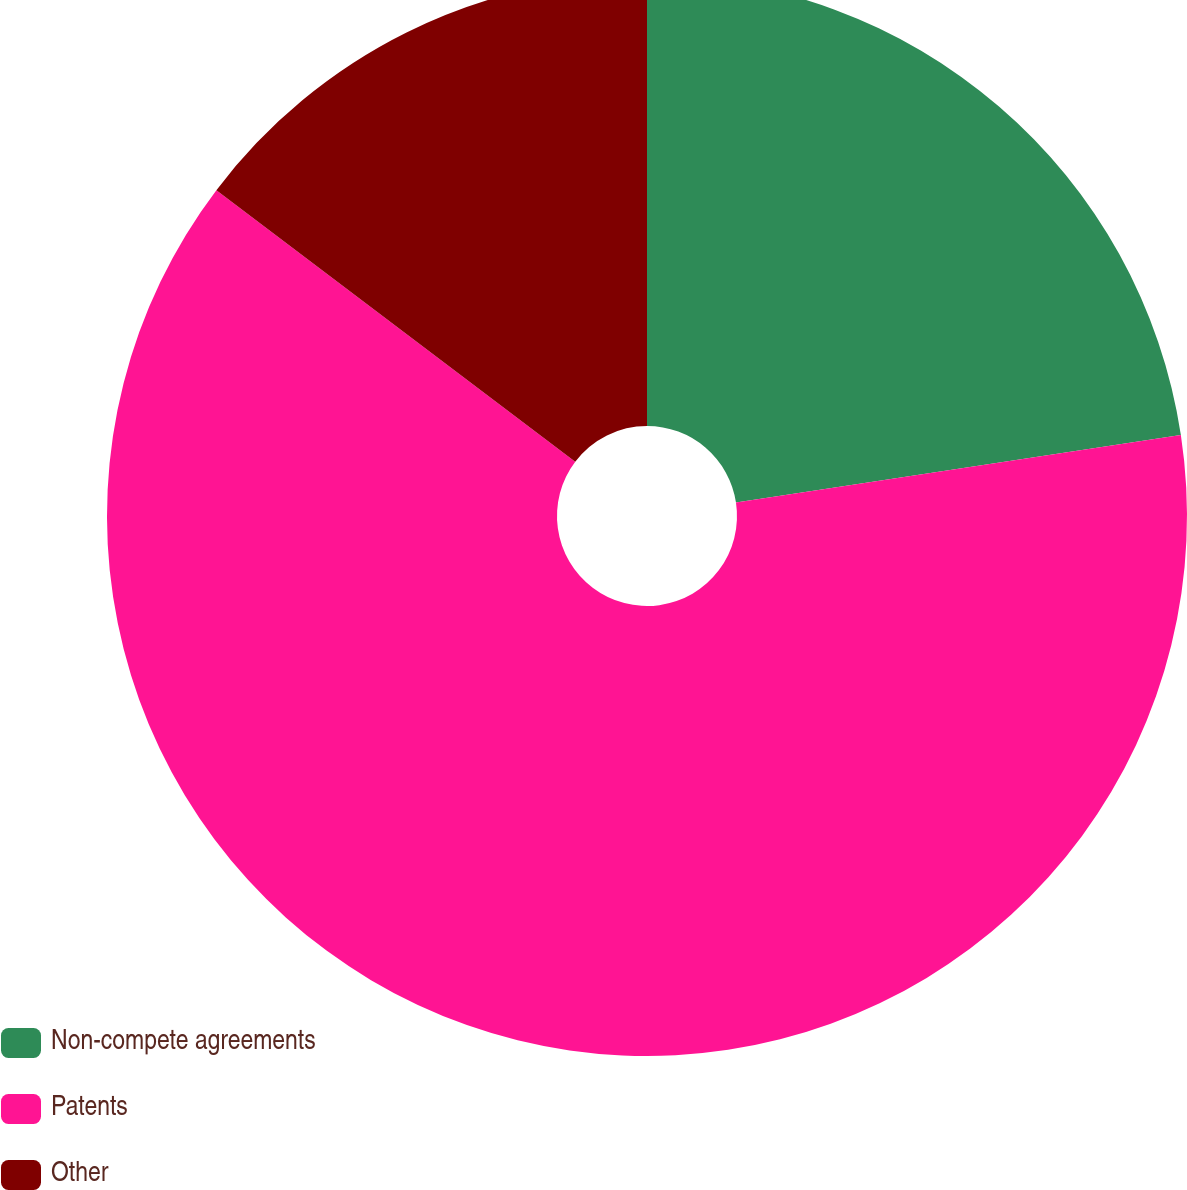Convert chart to OTSL. <chart><loc_0><loc_0><loc_500><loc_500><pie_chart><fcel>Non-compete agreements<fcel>Patents<fcel>Other<nl><fcel>22.6%<fcel>62.71%<fcel>14.69%<nl></chart> 